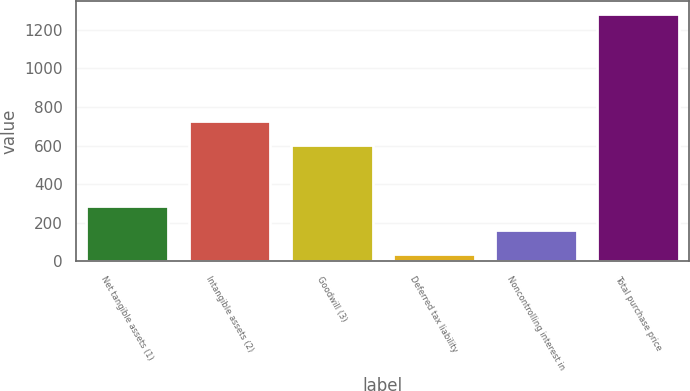<chart> <loc_0><loc_0><loc_500><loc_500><bar_chart><fcel>Net tangible assets (1)<fcel>Intangible assets (2)<fcel>Goodwill (3)<fcel>Deferred tax liability<fcel>Noncontrolling interest in<fcel>Total purchase price<nl><fcel>287.4<fcel>726.7<fcel>602<fcel>38<fcel>162.7<fcel>1285<nl></chart> 